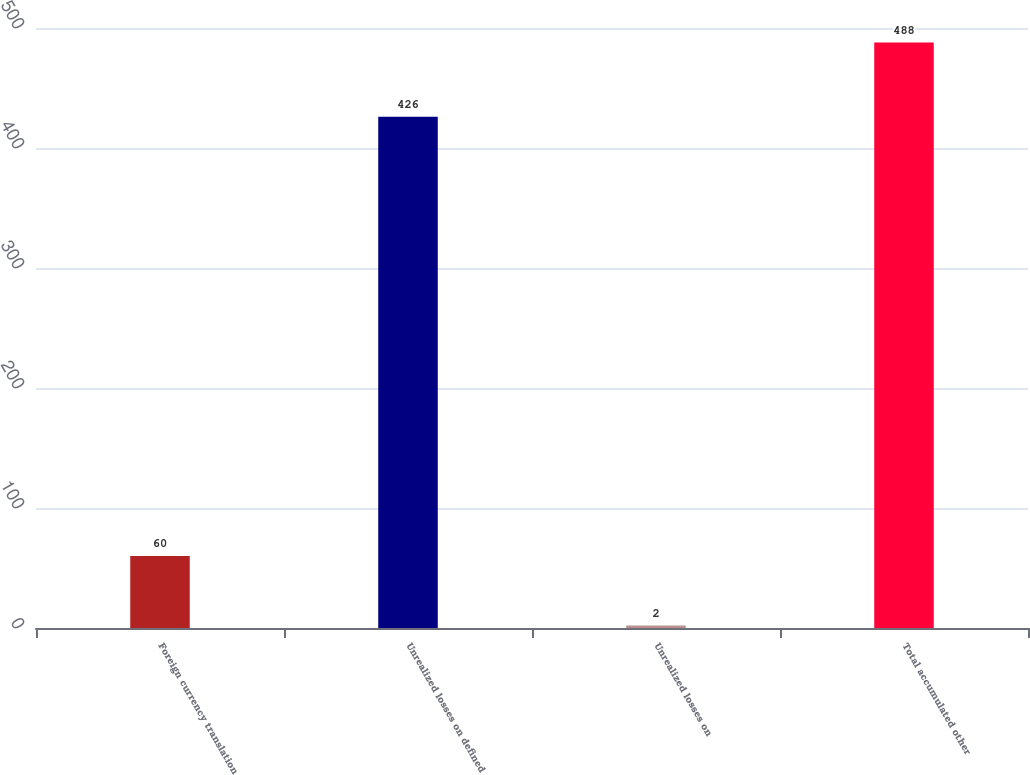Convert chart to OTSL. <chart><loc_0><loc_0><loc_500><loc_500><bar_chart><fcel>Foreign currency translation<fcel>Unrealized losses on defined<fcel>Unrealized losses on<fcel>Total accumulated other<nl><fcel>60<fcel>426<fcel>2<fcel>488<nl></chart> 